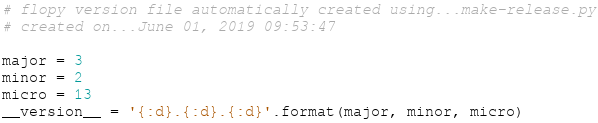Convert code to text. <code><loc_0><loc_0><loc_500><loc_500><_Python_># flopy version file automatically created using...make-release.py
# created on...June 01, 2019 09:53:47

major = 3
minor = 2
micro = 13
__version__ = '{:d}.{:d}.{:d}'.format(major, minor, micro)
</code> 